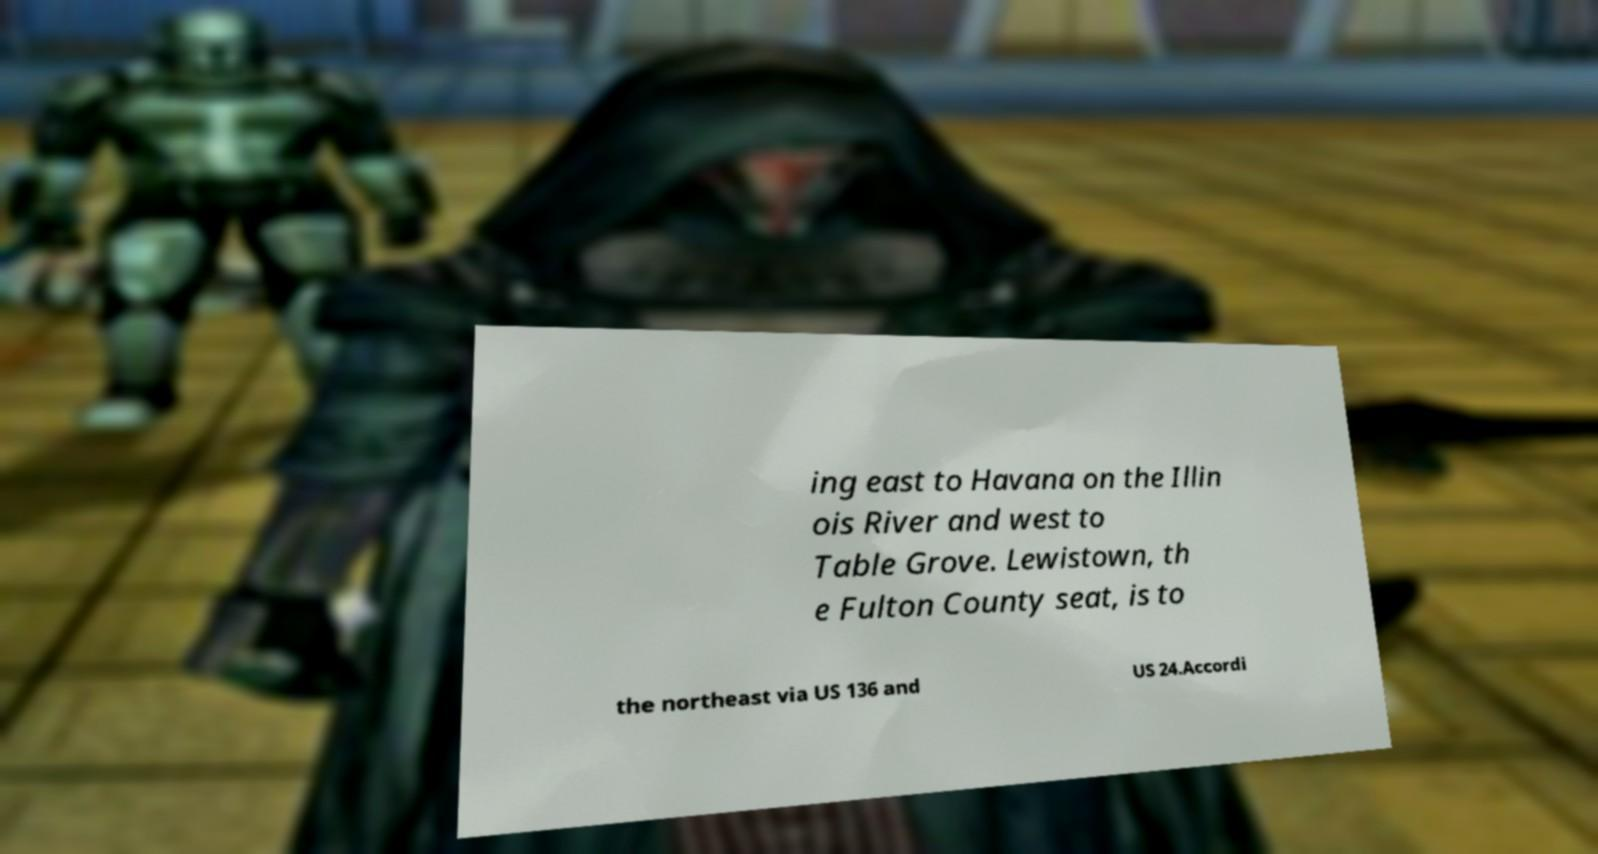What messages or text are displayed in this image? I need them in a readable, typed format. ing east to Havana on the Illin ois River and west to Table Grove. Lewistown, th e Fulton County seat, is to the northeast via US 136 and US 24.Accordi 